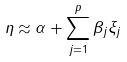<formula> <loc_0><loc_0><loc_500><loc_500>\eta \approx \alpha + \sum _ { j = 1 } ^ { p } \beta _ { j } \xi _ { j }</formula> 